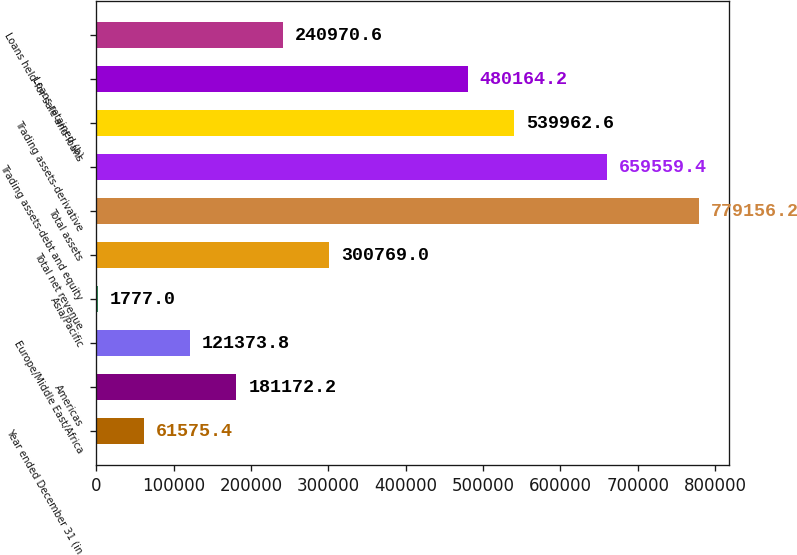Convert chart to OTSL. <chart><loc_0><loc_0><loc_500><loc_500><bar_chart><fcel>Year ended December 31 (in<fcel>Americas<fcel>Europe/Middle East/Africa<fcel>Asia/Pacific<fcel>Total net revenue<fcel>Total assets<fcel>Trading assets-debt and equity<fcel>Trading assets-derivative<fcel>Loans retained (b)<fcel>Loans held-for-sale and loans<nl><fcel>61575.4<fcel>181172<fcel>121374<fcel>1777<fcel>300769<fcel>779156<fcel>659559<fcel>539963<fcel>480164<fcel>240971<nl></chart> 